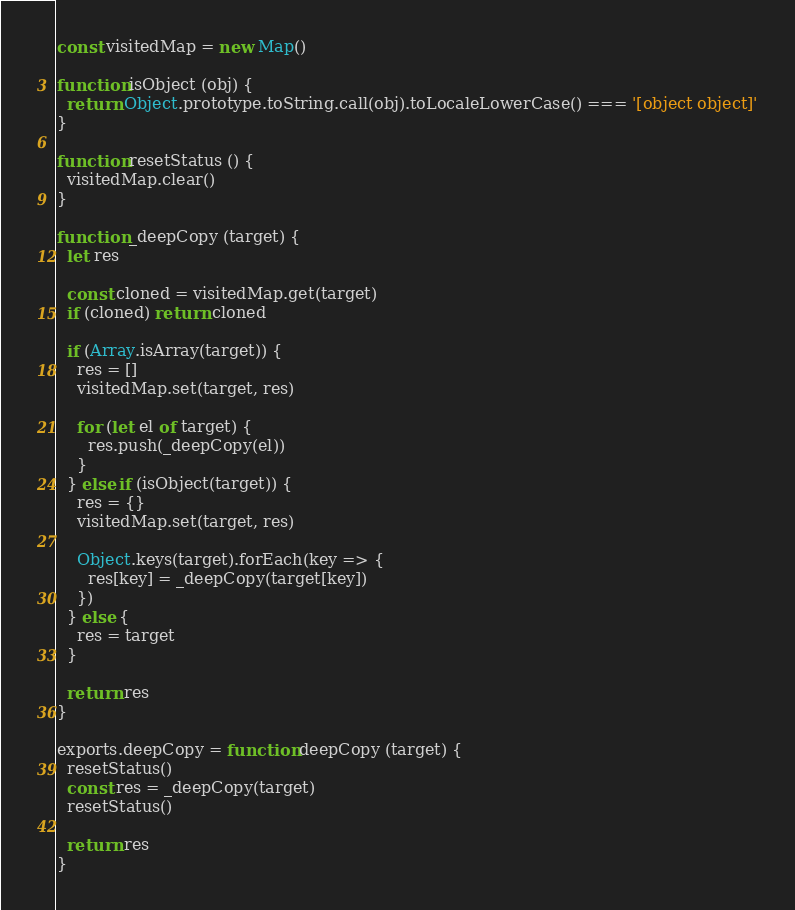Convert code to text. <code><loc_0><loc_0><loc_500><loc_500><_JavaScript_>const visitedMap = new Map()

function isObject (obj) {
  return Object.prototype.toString.call(obj).toLocaleLowerCase() === '[object object]'
}

function resetStatus () {
  visitedMap.clear()
}

function _deepCopy (target) {
  let res

  const cloned = visitedMap.get(target)
  if (cloned) return cloned

  if (Array.isArray(target)) {
    res = []
    visitedMap.set(target, res)

    for (let el of target) {
      res.push(_deepCopy(el))
    }
  } else if (isObject(target)) {
    res = {}
    visitedMap.set(target, res)

    Object.keys(target).forEach(key => {
      res[key] = _deepCopy(target[key])
    })
  } else {
    res = target
  }

  return res
}

exports.deepCopy = function deepCopy (target) {
  resetStatus()
  const res = _deepCopy(target)
  resetStatus()

  return res
}</code> 